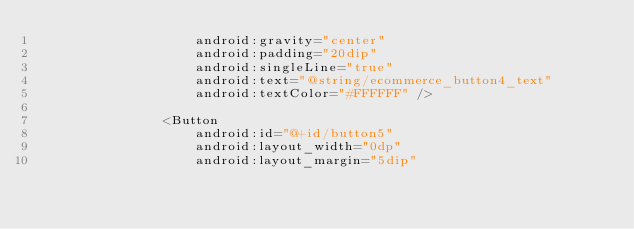<code> <loc_0><loc_0><loc_500><loc_500><_XML_>                    android:gravity="center"
                    android:padding="20dip"
                    android:singleLine="true"
                    android:text="@string/ecommerce_button4_text"
                    android:textColor="#FFFFFF" />

                <Button
                    android:id="@+id/button5"
                    android:layout_width="0dp"
                    android:layout_margin="5dip"</code> 